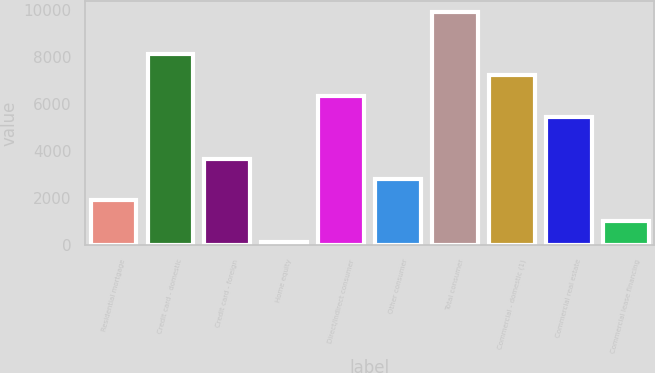Convert chart. <chart><loc_0><loc_0><loc_500><loc_500><bar_chart><fcel>Residential mortgage<fcel>Credit card - domestic<fcel>Credit card - foreign<fcel>Home equity<fcel>Direct/Indirect consumer<fcel>Other consumer<fcel>Total consumer<fcel>Commercial - domestic (1)<fcel>Commercial real estate<fcel>Commercial lease financing<nl><fcel>1909.6<fcel>8127.7<fcel>3686.2<fcel>133<fcel>6351.1<fcel>2797.9<fcel>9904.3<fcel>7239.4<fcel>5462.8<fcel>1021.3<nl></chart> 